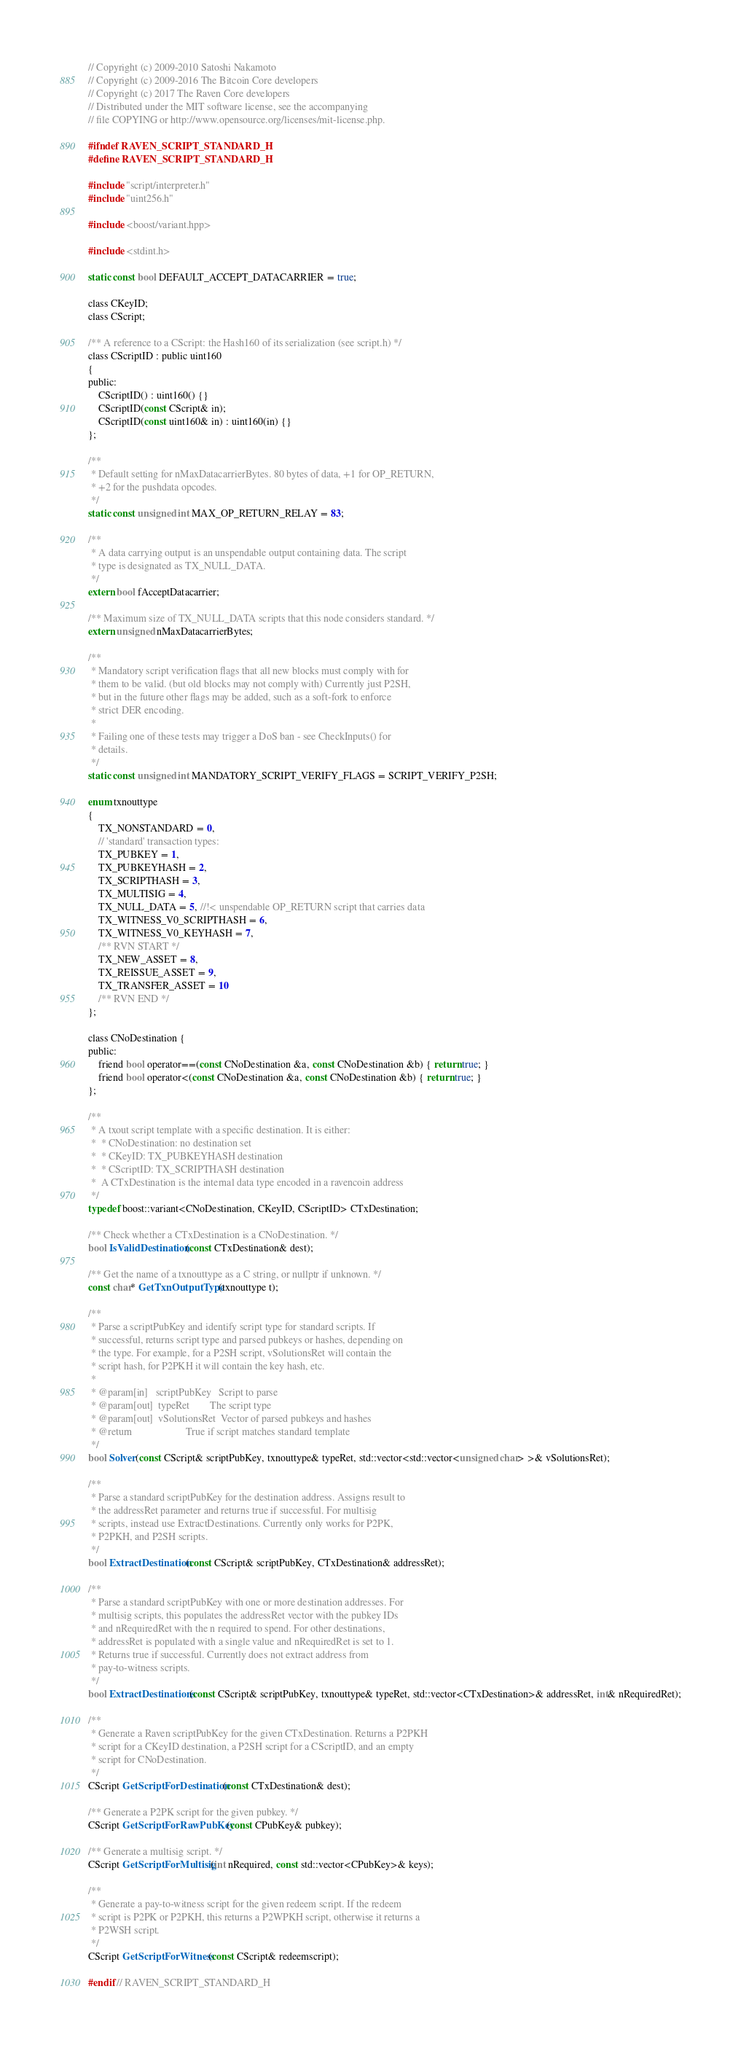Convert code to text. <code><loc_0><loc_0><loc_500><loc_500><_C_>// Copyright (c) 2009-2010 Satoshi Nakamoto
// Copyright (c) 2009-2016 The Bitcoin Core developers
// Copyright (c) 2017 The Raven Core developers
// Distributed under the MIT software license, see the accompanying
// file COPYING or http://www.opensource.org/licenses/mit-license.php.

#ifndef RAVEN_SCRIPT_STANDARD_H
#define RAVEN_SCRIPT_STANDARD_H

#include "script/interpreter.h"
#include "uint256.h"

#include <boost/variant.hpp>

#include <stdint.h>

static const bool DEFAULT_ACCEPT_DATACARRIER = true;

class CKeyID;
class CScript;

/** A reference to a CScript: the Hash160 of its serialization (see script.h) */
class CScriptID : public uint160
{
public:
    CScriptID() : uint160() {}
    CScriptID(const CScript& in);
    CScriptID(const uint160& in) : uint160(in) {}
};

/**
 * Default setting for nMaxDatacarrierBytes. 80 bytes of data, +1 for OP_RETURN,
 * +2 for the pushdata opcodes.
 */
static const unsigned int MAX_OP_RETURN_RELAY = 83;

/**
 * A data carrying output is an unspendable output containing data. The script
 * type is designated as TX_NULL_DATA.
 */
extern bool fAcceptDatacarrier;

/** Maximum size of TX_NULL_DATA scripts that this node considers standard. */
extern unsigned nMaxDatacarrierBytes;

/**
 * Mandatory script verification flags that all new blocks must comply with for
 * them to be valid. (but old blocks may not comply with) Currently just P2SH,
 * but in the future other flags may be added, such as a soft-fork to enforce
 * strict DER encoding.
 *
 * Failing one of these tests may trigger a DoS ban - see CheckInputs() for
 * details.
 */
static const unsigned int MANDATORY_SCRIPT_VERIFY_FLAGS = SCRIPT_VERIFY_P2SH;

enum txnouttype
{
    TX_NONSTANDARD = 0,
    // 'standard' transaction types:
    TX_PUBKEY = 1,
    TX_PUBKEYHASH = 2,
    TX_SCRIPTHASH = 3,
    TX_MULTISIG = 4,
    TX_NULL_DATA = 5, //!< unspendable OP_RETURN script that carries data
    TX_WITNESS_V0_SCRIPTHASH = 6,
    TX_WITNESS_V0_KEYHASH = 7,
    /** RVN START */
    TX_NEW_ASSET = 8,
    TX_REISSUE_ASSET = 9,
    TX_TRANSFER_ASSET = 10
    /** RVN END */
};

class CNoDestination {
public:
    friend bool operator==(const CNoDestination &a, const CNoDestination &b) { return true; }
    friend bool operator<(const CNoDestination &a, const CNoDestination &b) { return true; }
};

/**
 * A txout script template with a specific destination. It is either:
 *  * CNoDestination: no destination set
 *  * CKeyID: TX_PUBKEYHASH destination
 *  * CScriptID: TX_SCRIPTHASH destination
 *  A CTxDestination is the internal data type encoded in a ravencoin address
 */
typedef boost::variant<CNoDestination, CKeyID, CScriptID> CTxDestination;

/** Check whether a CTxDestination is a CNoDestination. */
bool IsValidDestination(const CTxDestination& dest);

/** Get the name of a txnouttype as a C string, or nullptr if unknown. */
const char* GetTxnOutputType(txnouttype t);

/**
 * Parse a scriptPubKey and identify script type for standard scripts. If
 * successful, returns script type and parsed pubkeys or hashes, depending on
 * the type. For example, for a P2SH script, vSolutionsRet will contain the
 * script hash, for P2PKH it will contain the key hash, etc.
 *
 * @param[in]   scriptPubKey   Script to parse
 * @param[out]  typeRet        The script type
 * @param[out]  vSolutionsRet  Vector of parsed pubkeys and hashes
 * @return                     True if script matches standard template
 */
bool Solver(const CScript& scriptPubKey, txnouttype& typeRet, std::vector<std::vector<unsigned char> >& vSolutionsRet);

/**
 * Parse a standard scriptPubKey for the destination address. Assigns result to
 * the addressRet parameter and returns true if successful. For multisig
 * scripts, instead use ExtractDestinations. Currently only works for P2PK,
 * P2PKH, and P2SH scripts.
 */
bool ExtractDestination(const CScript& scriptPubKey, CTxDestination& addressRet);

/**
 * Parse a standard scriptPubKey with one or more destination addresses. For
 * multisig scripts, this populates the addressRet vector with the pubkey IDs
 * and nRequiredRet with the n required to spend. For other destinations,
 * addressRet is populated with a single value and nRequiredRet is set to 1.
 * Returns true if successful. Currently does not extract address from
 * pay-to-witness scripts.
 */
bool ExtractDestinations(const CScript& scriptPubKey, txnouttype& typeRet, std::vector<CTxDestination>& addressRet, int& nRequiredRet);

/**
 * Generate a Raven scriptPubKey for the given CTxDestination. Returns a P2PKH
 * script for a CKeyID destination, a P2SH script for a CScriptID, and an empty
 * script for CNoDestination.
 */
CScript GetScriptForDestination(const CTxDestination& dest);

/** Generate a P2PK script for the given pubkey. */
CScript GetScriptForRawPubKey(const CPubKey& pubkey);

/** Generate a multisig script. */
CScript GetScriptForMultisig(int nRequired, const std::vector<CPubKey>& keys);

/**
 * Generate a pay-to-witness script for the given redeem script. If the redeem
 * script is P2PK or P2PKH, this returns a P2WPKH script, otherwise it returns a
 * P2WSH script.
 */
CScript GetScriptForWitness(const CScript& redeemscript);

#endif // RAVEN_SCRIPT_STANDARD_H
</code> 